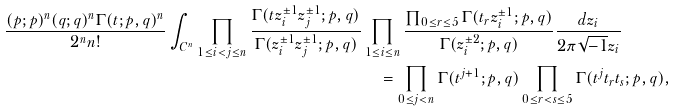Convert formula to latex. <formula><loc_0><loc_0><loc_500><loc_500>\frac { ( p ; p ) ^ { n } ( q ; q ) ^ { n } \Gamma ( t ; p , q ) ^ { n } } { 2 ^ { n } n ! } \int _ { C ^ { n } } \prod _ { 1 \leq i < j \leq n } \frac { \Gamma ( t z _ { i } ^ { \pm 1 } z _ { j } ^ { \pm 1 } ; p , q ) } { \Gamma ( z _ { i } ^ { \pm 1 } z _ { j } ^ { \pm 1 } ; p , q ) } & \prod _ { 1 \leq i \leq n } \frac { \prod _ { 0 \leq r \leq 5 } \Gamma ( t _ { r } z _ { i } ^ { \pm 1 } ; p , q ) } { \Gamma ( z _ { i } ^ { \pm 2 } ; p , q ) } \frac { d z _ { i } } { 2 \pi \sqrt { - 1 } z _ { i } } \\ & \quad = \prod _ { 0 \leq j < n } \Gamma ( t ^ { j + 1 } ; p , q ) \prod _ { 0 \leq r < s \leq 5 } \Gamma ( t ^ { j } t _ { r } t _ { s } ; p , q ) ,</formula> 